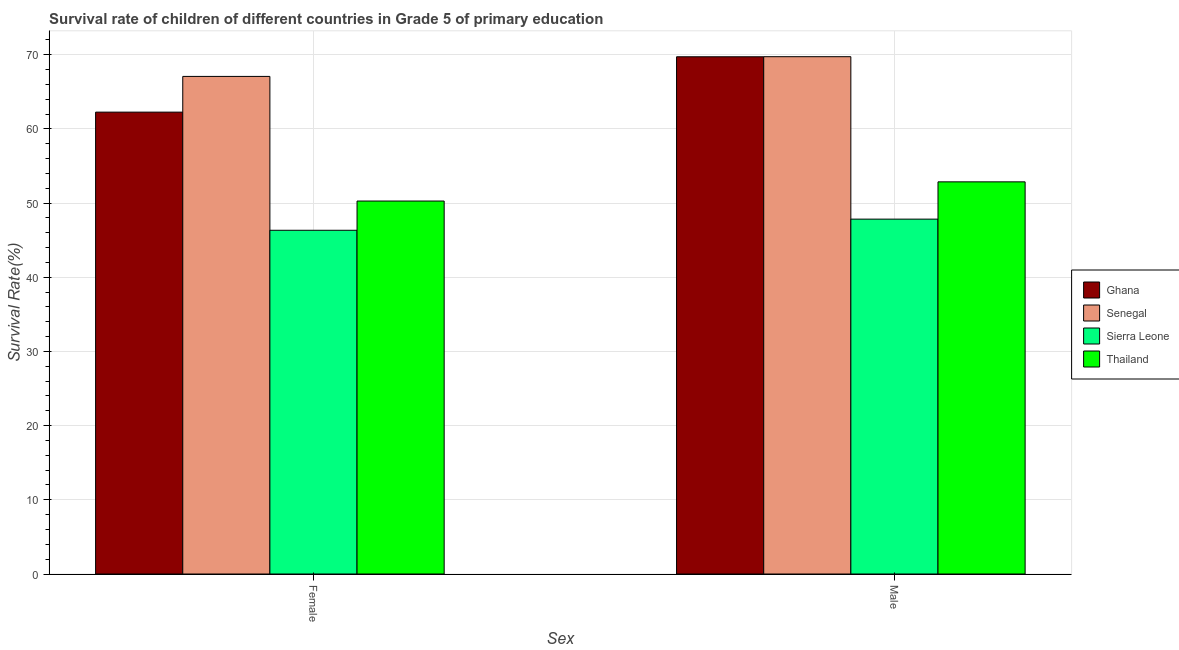How many groups of bars are there?
Offer a very short reply. 2. Are the number of bars per tick equal to the number of legend labels?
Your answer should be compact. Yes. What is the survival rate of male students in primary education in Senegal?
Your response must be concise. 69.72. Across all countries, what is the maximum survival rate of female students in primary education?
Offer a terse response. 67.07. Across all countries, what is the minimum survival rate of male students in primary education?
Your answer should be compact. 47.83. In which country was the survival rate of male students in primary education maximum?
Give a very brief answer. Senegal. In which country was the survival rate of male students in primary education minimum?
Make the answer very short. Sierra Leone. What is the total survival rate of female students in primary education in the graph?
Offer a very short reply. 225.91. What is the difference between the survival rate of male students in primary education in Senegal and that in Ghana?
Your response must be concise. 0.01. What is the difference between the survival rate of female students in primary education in Senegal and the survival rate of male students in primary education in Ghana?
Make the answer very short. -2.65. What is the average survival rate of male students in primary education per country?
Ensure brevity in your answer.  60.03. What is the difference between the survival rate of female students in primary education and survival rate of male students in primary education in Sierra Leone?
Your answer should be very brief. -1.5. In how many countries, is the survival rate of female students in primary education greater than 62 %?
Your answer should be compact. 2. What is the ratio of the survival rate of male students in primary education in Sierra Leone to that in Senegal?
Your response must be concise. 0.69. Is the survival rate of female students in primary education in Ghana less than that in Sierra Leone?
Offer a terse response. No. In how many countries, is the survival rate of female students in primary education greater than the average survival rate of female students in primary education taken over all countries?
Offer a very short reply. 2. What does the 4th bar from the left in Female represents?
Offer a terse response. Thailand. What does the 1st bar from the right in Female represents?
Your answer should be compact. Thailand. How many bars are there?
Offer a very short reply. 8. Are the values on the major ticks of Y-axis written in scientific E-notation?
Provide a succinct answer. No. Does the graph contain any zero values?
Offer a terse response. No. Does the graph contain grids?
Your answer should be compact. Yes. How many legend labels are there?
Offer a terse response. 4. How are the legend labels stacked?
Provide a succinct answer. Vertical. What is the title of the graph?
Your answer should be very brief. Survival rate of children of different countries in Grade 5 of primary education. What is the label or title of the X-axis?
Keep it short and to the point. Sex. What is the label or title of the Y-axis?
Keep it short and to the point. Survival Rate(%). What is the Survival Rate(%) in Ghana in Female?
Offer a terse response. 62.25. What is the Survival Rate(%) in Senegal in Female?
Offer a very short reply. 67.07. What is the Survival Rate(%) in Sierra Leone in Female?
Ensure brevity in your answer.  46.33. What is the Survival Rate(%) of Thailand in Female?
Make the answer very short. 50.27. What is the Survival Rate(%) in Ghana in Male?
Make the answer very short. 69.71. What is the Survival Rate(%) in Senegal in Male?
Your answer should be very brief. 69.72. What is the Survival Rate(%) in Sierra Leone in Male?
Provide a succinct answer. 47.83. What is the Survival Rate(%) in Thailand in Male?
Your answer should be compact. 52.86. Across all Sex, what is the maximum Survival Rate(%) in Ghana?
Give a very brief answer. 69.71. Across all Sex, what is the maximum Survival Rate(%) of Senegal?
Keep it short and to the point. 69.72. Across all Sex, what is the maximum Survival Rate(%) of Sierra Leone?
Offer a terse response. 47.83. Across all Sex, what is the maximum Survival Rate(%) in Thailand?
Your answer should be compact. 52.86. Across all Sex, what is the minimum Survival Rate(%) in Ghana?
Give a very brief answer. 62.25. Across all Sex, what is the minimum Survival Rate(%) in Senegal?
Offer a very short reply. 67.07. Across all Sex, what is the minimum Survival Rate(%) in Sierra Leone?
Your response must be concise. 46.33. Across all Sex, what is the minimum Survival Rate(%) of Thailand?
Give a very brief answer. 50.27. What is the total Survival Rate(%) in Ghana in the graph?
Your answer should be very brief. 131.97. What is the total Survival Rate(%) in Senegal in the graph?
Provide a short and direct response. 136.79. What is the total Survival Rate(%) of Sierra Leone in the graph?
Give a very brief answer. 94.16. What is the total Survival Rate(%) in Thailand in the graph?
Provide a succinct answer. 103.12. What is the difference between the Survival Rate(%) in Ghana in Female and that in Male?
Make the answer very short. -7.46. What is the difference between the Survival Rate(%) of Senegal in Female and that in Male?
Offer a very short reply. -2.66. What is the difference between the Survival Rate(%) of Sierra Leone in Female and that in Male?
Provide a succinct answer. -1.5. What is the difference between the Survival Rate(%) of Thailand in Female and that in Male?
Keep it short and to the point. -2.59. What is the difference between the Survival Rate(%) of Ghana in Female and the Survival Rate(%) of Senegal in Male?
Provide a succinct answer. -7.47. What is the difference between the Survival Rate(%) of Ghana in Female and the Survival Rate(%) of Sierra Leone in Male?
Your answer should be compact. 14.42. What is the difference between the Survival Rate(%) in Ghana in Female and the Survival Rate(%) in Thailand in Male?
Your response must be concise. 9.4. What is the difference between the Survival Rate(%) in Senegal in Female and the Survival Rate(%) in Sierra Leone in Male?
Give a very brief answer. 19.24. What is the difference between the Survival Rate(%) in Senegal in Female and the Survival Rate(%) in Thailand in Male?
Provide a succinct answer. 14.21. What is the difference between the Survival Rate(%) in Sierra Leone in Female and the Survival Rate(%) in Thailand in Male?
Keep it short and to the point. -6.53. What is the average Survival Rate(%) of Ghana per Sex?
Your answer should be compact. 65.98. What is the average Survival Rate(%) of Senegal per Sex?
Give a very brief answer. 68.39. What is the average Survival Rate(%) of Sierra Leone per Sex?
Give a very brief answer. 47.08. What is the average Survival Rate(%) in Thailand per Sex?
Provide a short and direct response. 51.56. What is the difference between the Survival Rate(%) in Ghana and Survival Rate(%) in Senegal in Female?
Provide a short and direct response. -4.81. What is the difference between the Survival Rate(%) of Ghana and Survival Rate(%) of Sierra Leone in Female?
Give a very brief answer. 15.92. What is the difference between the Survival Rate(%) of Ghana and Survival Rate(%) of Thailand in Female?
Provide a short and direct response. 11.98. What is the difference between the Survival Rate(%) in Senegal and Survival Rate(%) in Sierra Leone in Female?
Provide a short and direct response. 20.74. What is the difference between the Survival Rate(%) in Senegal and Survival Rate(%) in Thailand in Female?
Offer a very short reply. 16.8. What is the difference between the Survival Rate(%) in Sierra Leone and Survival Rate(%) in Thailand in Female?
Your response must be concise. -3.94. What is the difference between the Survival Rate(%) in Ghana and Survival Rate(%) in Senegal in Male?
Provide a succinct answer. -0.01. What is the difference between the Survival Rate(%) of Ghana and Survival Rate(%) of Sierra Leone in Male?
Offer a terse response. 21.88. What is the difference between the Survival Rate(%) of Ghana and Survival Rate(%) of Thailand in Male?
Provide a short and direct response. 16.86. What is the difference between the Survival Rate(%) in Senegal and Survival Rate(%) in Sierra Leone in Male?
Your response must be concise. 21.9. What is the difference between the Survival Rate(%) of Senegal and Survival Rate(%) of Thailand in Male?
Your response must be concise. 16.87. What is the difference between the Survival Rate(%) of Sierra Leone and Survival Rate(%) of Thailand in Male?
Provide a short and direct response. -5.03. What is the ratio of the Survival Rate(%) in Ghana in Female to that in Male?
Give a very brief answer. 0.89. What is the ratio of the Survival Rate(%) in Senegal in Female to that in Male?
Make the answer very short. 0.96. What is the ratio of the Survival Rate(%) of Sierra Leone in Female to that in Male?
Your response must be concise. 0.97. What is the ratio of the Survival Rate(%) in Thailand in Female to that in Male?
Offer a terse response. 0.95. What is the difference between the highest and the second highest Survival Rate(%) of Ghana?
Your response must be concise. 7.46. What is the difference between the highest and the second highest Survival Rate(%) of Senegal?
Ensure brevity in your answer.  2.66. What is the difference between the highest and the second highest Survival Rate(%) in Sierra Leone?
Provide a short and direct response. 1.5. What is the difference between the highest and the second highest Survival Rate(%) of Thailand?
Keep it short and to the point. 2.59. What is the difference between the highest and the lowest Survival Rate(%) of Ghana?
Offer a terse response. 7.46. What is the difference between the highest and the lowest Survival Rate(%) in Senegal?
Your answer should be very brief. 2.66. What is the difference between the highest and the lowest Survival Rate(%) of Sierra Leone?
Ensure brevity in your answer.  1.5. What is the difference between the highest and the lowest Survival Rate(%) in Thailand?
Offer a terse response. 2.59. 